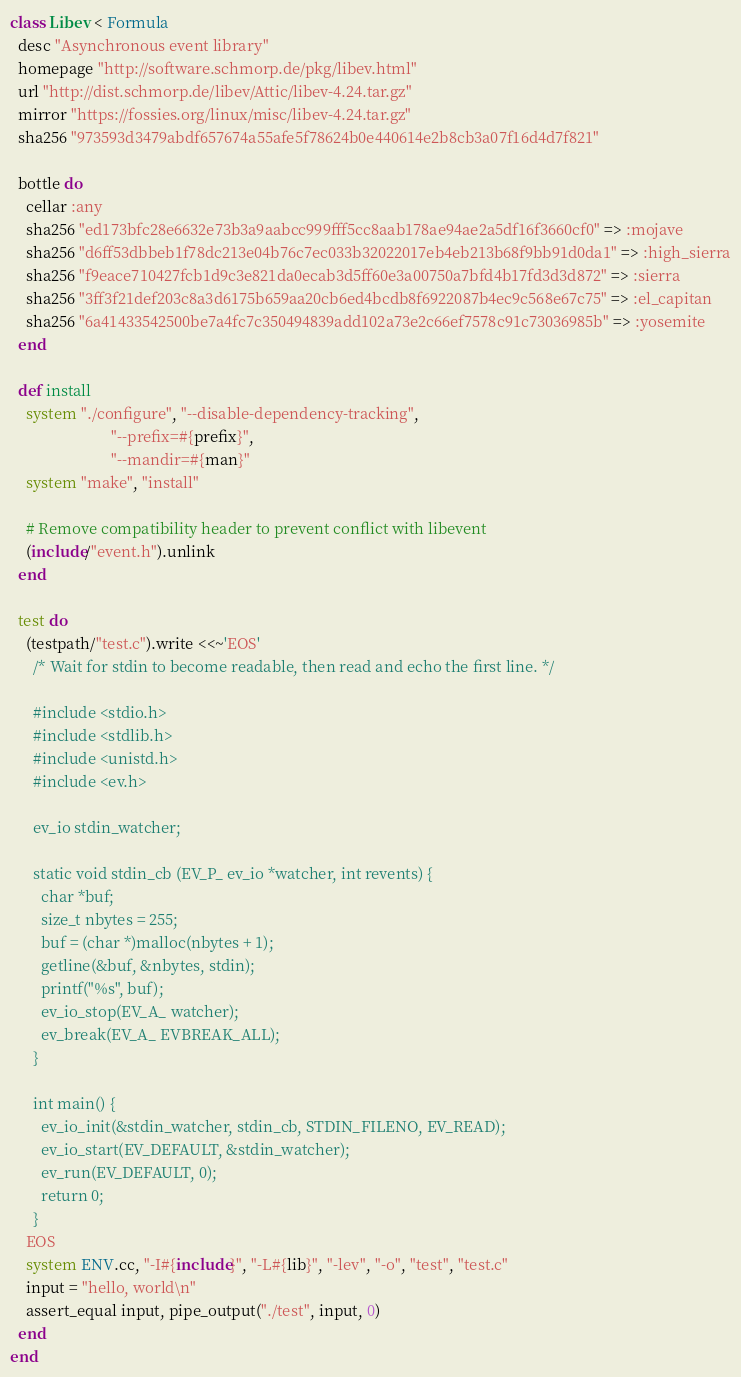Convert code to text. <code><loc_0><loc_0><loc_500><loc_500><_Ruby_>class Libev < Formula
  desc "Asynchronous event library"
  homepage "http://software.schmorp.de/pkg/libev.html"
  url "http://dist.schmorp.de/libev/Attic/libev-4.24.tar.gz"
  mirror "https://fossies.org/linux/misc/libev-4.24.tar.gz"
  sha256 "973593d3479abdf657674a55afe5f78624b0e440614e2b8cb3a07f16d4d7f821"

  bottle do
    cellar :any
    sha256 "ed173bfc28e6632e73b3a9aabcc999fff5cc8aab178ae94ae2a5df16f3660cf0" => :mojave
    sha256 "d6ff53dbbeb1f78dc213e04b76c7ec033b32022017eb4eb213b68f9bb91d0da1" => :high_sierra
    sha256 "f9eace710427fcb1d9c3e821da0ecab3d5ff60e3a00750a7bfd4b17fd3d3d872" => :sierra
    sha256 "3ff3f21def203c8a3d6175b659aa20cb6ed4bcdb8f6922087b4ec9c568e67c75" => :el_capitan
    sha256 "6a41433542500be7a4fc7c350494839add102a73e2c66ef7578c91c73036985b" => :yosemite
  end

  def install
    system "./configure", "--disable-dependency-tracking",
                          "--prefix=#{prefix}",
                          "--mandir=#{man}"
    system "make", "install"

    # Remove compatibility header to prevent conflict with libevent
    (include/"event.h").unlink
  end

  test do
    (testpath/"test.c").write <<~'EOS'
      /* Wait for stdin to become readable, then read and echo the first line. */

      #include <stdio.h>
      #include <stdlib.h>
      #include <unistd.h>
      #include <ev.h>

      ev_io stdin_watcher;

      static void stdin_cb (EV_P_ ev_io *watcher, int revents) {
        char *buf;
        size_t nbytes = 255;
        buf = (char *)malloc(nbytes + 1);
        getline(&buf, &nbytes, stdin);
        printf("%s", buf);
        ev_io_stop(EV_A_ watcher);
        ev_break(EV_A_ EVBREAK_ALL);
      }

      int main() {
        ev_io_init(&stdin_watcher, stdin_cb, STDIN_FILENO, EV_READ);
        ev_io_start(EV_DEFAULT, &stdin_watcher);
        ev_run(EV_DEFAULT, 0);
        return 0;
      }
    EOS
    system ENV.cc, "-I#{include}", "-L#{lib}", "-lev", "-o", "test", "test.c"
    input = "hello, world\n"
    assert_equal input, pipe_output("./test", input, 0)
  end
end
</code> 